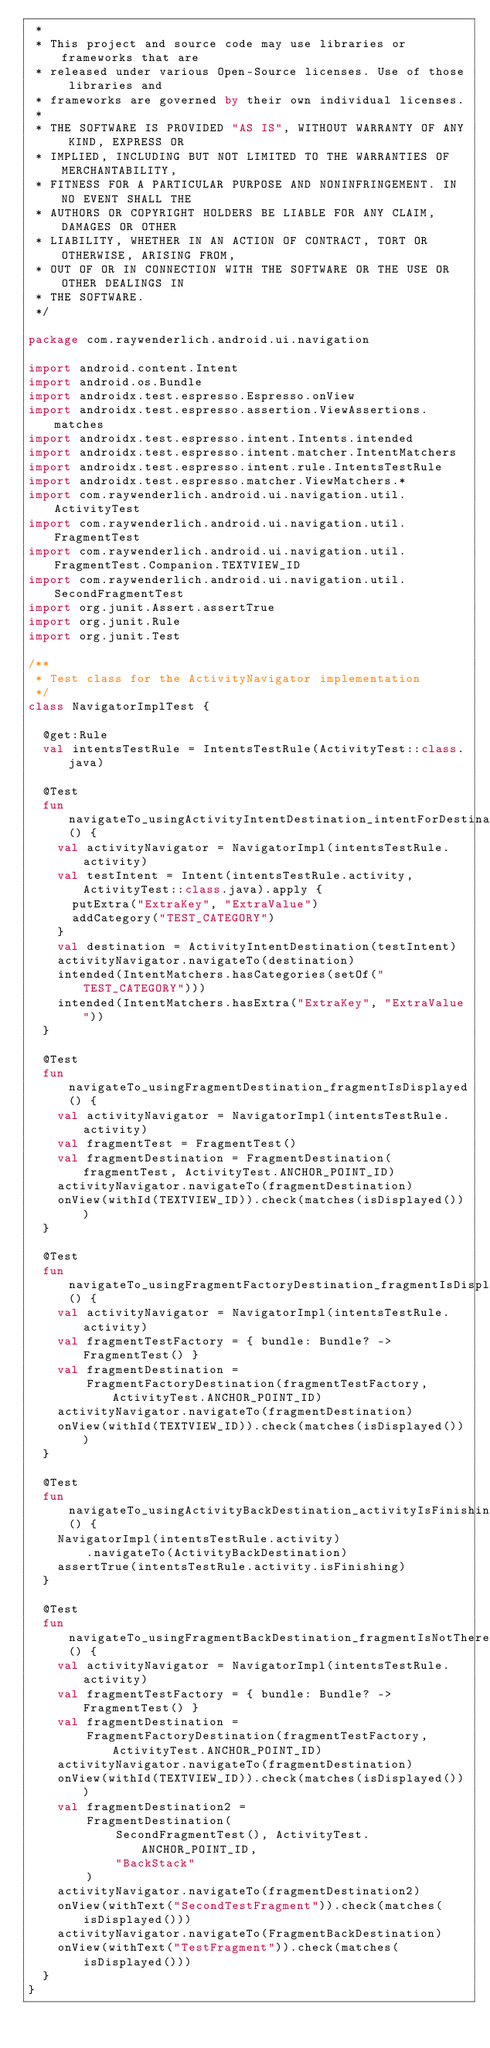<code> <loc_0><loc_0><loc_500><loc_500><_Kotlin_> *
 * This project and source code may use libraries or frameworks that are
 * released under various Open-Source licenses. Use of those libraries and
 * frameworks are governed by their own individual licenses.
 *
 * THE SOFTWARE IS PROVIDED "AS IS", WITHOUT WARRANTY OF ANY KIND, EXPRESS OR
 * IMPLIED, INCLUDING BUT NOT LIMITED TO THE WARRANTIES OF MERCHANTABILITY,
 * FITNESS FOR A PARTICULAR PURPOSE AND NONINFRINGEMENT. IN NO EVENT SHALL THE
 * AUTHORS OR COPYRIGHT HOLDERS BE LIABLE FOR ANY CLAIM, DAMAGES OR OTHER
 * LIABILITY, WHETHER IN AN ACTION OF CONTRACT, TORT OR OTHERWISE, ARISING FROM,
 * OUT OF OR IN CONNECTION WITH THE SOFTWARE OR THE USE OR OTHER DEALINGS IN
 * THE SOFTWARE.
 */

package com.raywenderlich.android.ui.navigation

import android.content.Intent
import android.os.Bundle
import androidx.test.espresso.Espresso.onView
import androidx.test.espresso.assertion.ViewAssertions.matches
import androidx.test.espresso.intent.Intents.intended
import androidx.test.espresso.intent.matcher.IntentMatchers
import androidx.test.espresso.intent.rule.IntentsTestRule
import androidx.test.espresso.matcher.ViewMatchers.*
import com.raywenderlich.android.ui.navigation.util.ActivityTest
import com.raywenderlich.android.ui.navigation.util.FragmentTest
import com.raywenderlich.android.ui.navigation.util.FragmentTest.Companion.TEXTVIEW_ID
import com.raywenderlich.android.ui.navigation.util.SecondFragmentTest
import org.junit.Assert.assertTrue
import org.junit.Rule
import org.junit.Test

/**
 * Test class for the ActivityNavigator implementation
 */
class NavigatorImplTest {

  @get:Rule
  val intentsTestRule = IntentsTestRule(ActivityTest::class.java)

  @Test
  fun navigateTo_usingActivityIntentDestination_intentForDestinationLaunched() {
    val activityNavigator = NavigatorImpl(intentsTestRule.activity)
    val testIntent = Intent(intentsTestRule.activity, ActivityTest::class.java).apply {
      putExtra("ExtraKey", "ExtraValue")
      addCategory("TEST_CATEGORY")
    }
    val destination = ActivityIntentDestination(testIntent)
    activityNavigator.navigateTo(destination)
    intended(IntentMatchers.hasCategories(setOf("TEST_CATEGORY")))
    intended(IntentMatchers.hasExtra("ExtraKey", "ExtraValue"))
  }

  @Test
  fun navigateTo_usingFragmentDestination_fragmentIsDisplayed() {
    val activityNavigator = NavigatorImpl(intentsTestRule.activity)
    val fragmentTest = FragmentTest()
    val fragmentDestination = FragmentDestination(fragmentTest, ActivityTest.ANCHOR_POINT_ID)
    activityNavigator.navigateTo(fragmentDestination)
    onView(withId(TEXTVIEW_ID)).check(matches(isDisplayed()))
  }

  @Test
  fun navigateTo_usingFragmentFactoryDestination_fragmentIsDisplayed() {
    val activityNavigator = NavigatorImpl(intentsTestRule.activity)
    val fragmentTestFactory = { bundle: Bundle? -> FragmentTest() }
    val fragmentDestination =
        FragmentFactoryDestination(fragmentTestFactory, ActivityTest.ANCHOR_POINT_ID)
    activityNavigator.navigateTo(fragmentDestination)
    onView(withId(TEXTVIEW_ID)).check(matches(isDisplayed()))
  }

  @Test
  fun navigateTo_usingActivityBackDestination_activityIsFinishing() {
    NavigatorImpl(intentsTestRule.activity)
        .navigateTo(ActivityBackDestination)
    assertTrue(intentsTestRule.activity.isFinishing)
  }

  @Test
  fun navigateTo_usingFragmentBackDestination_fragmentIsNotThere() {
    val activityNavigator = NavigatorImpl(intentsTestRule.activity)
    val fragmentTestFactory = { bundle: Bundle? -> FragmentTest() }
    val fragmentDestination =
        FragmentFactoryDestination(fragmentTestFactory, ActivityTest.ANCHOR_POINT_ID)
    activityNavigator.navigateTo(fragmentDestination)
    onView(withId(TEXTVIEW_ID)).check(matches(isDisplayed()))
    val fragmentDestination2 =
        FragmentDestination(
            SecondFragmentTest(), ActivityTest.ANCHOR_POINT_ID,
            "BackStack"
        )
    activityNavigator.navigateTo(fragmentDestination2)
    onView(withText("SecondTestFragment")).check(matches(isDisplayed()))
    activityNavigator.navigateTo(FragmentBackDestination)
    onView(withText("TestFragment")).check(matches(isDisplayed()))
  }
}</code> 